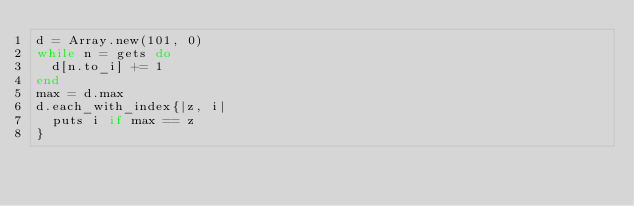Convert code to text. <code><loc_0><loc_0><loc_500><loc_500><_Ruby_>d = Array.new(101, 0)
while n = gets do
  d[n.to_i] += 1
end
max = d.max
d.each_with_index{|z, i|
  puts i if max == z
}</code> 